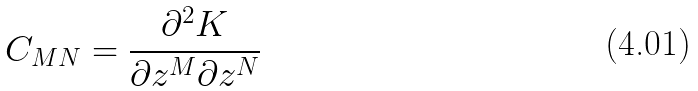<formula> <loc_0><loc_0><loc_500><loc_500>C _ { M N } = \frac { \partial ^ { 2 } K } { \partial z ^ { M } \partial z ^ { N } }</formula> 